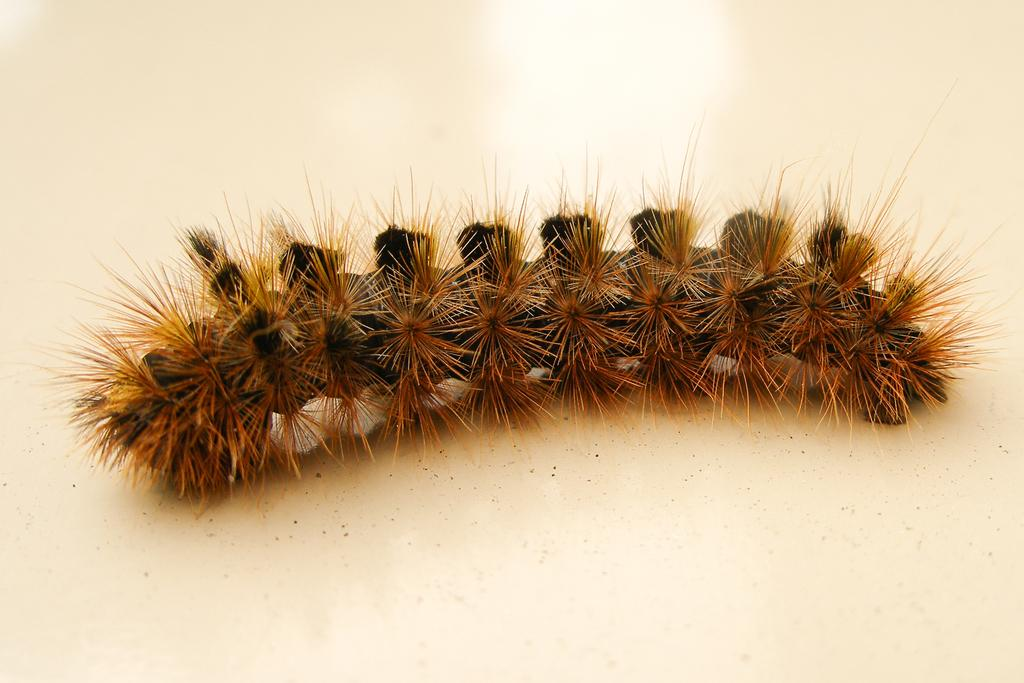What type of creature is present in the image? There is an insect in the image. Can you identify the specific type of insect? The insect appears to be a caterpillar. Where is the caterpillar located in the image? The caterpillar is on an object in the image. How does the caterpillar express its feelings in the image? The image does not depict the caterpillar expressing any feelings, as insects do not have the ability to express emotions in the same way as humans or other animals. 